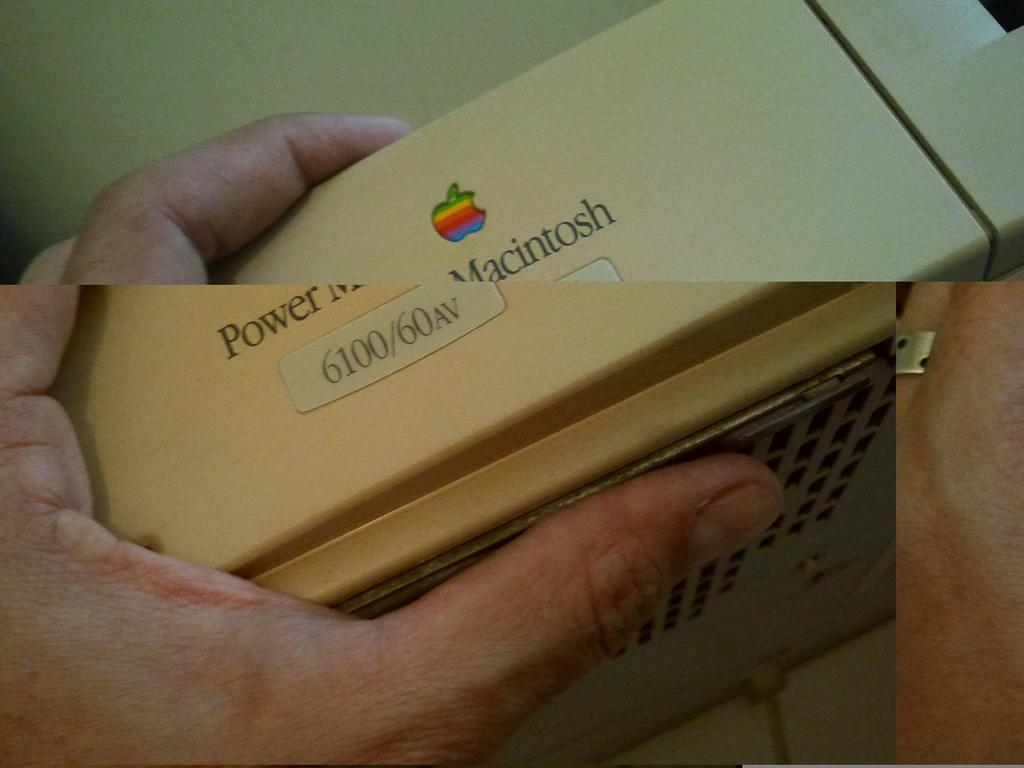<image>
Share a concise interpretation of the image provided. A person is holding an Apple computer that says Power Macintosh. 